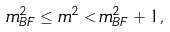<formula> <loc_0><loc_0><loc_500><loc_500>m ^ { 2 } _ { B F } \leq m ^ { 2 } < m ^ { 2 } _ { B F } + 1 ,</formula> 